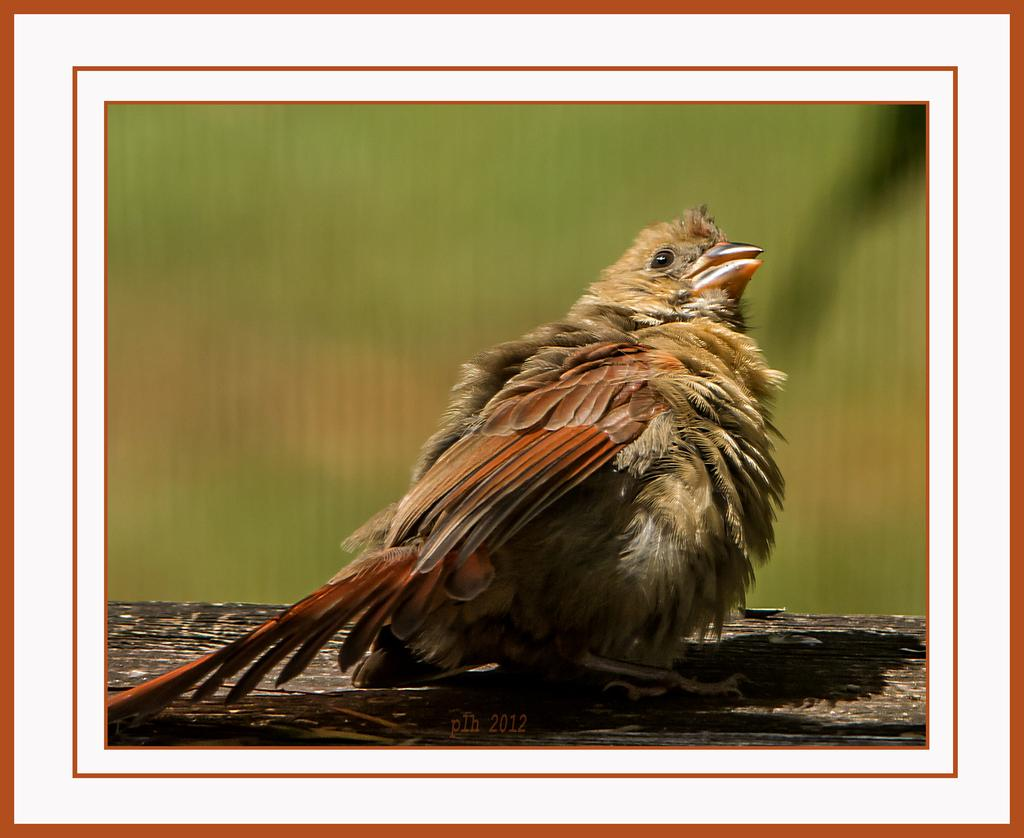What type of animal is in the image? There is a bird in the image. Can you describe the bird's appearance? The bird has brown and cream colors. Where is the bird located in the image? The bird is on a wooden surface. What color is the background of the image? The background of the image is green. What type of stew is being cooked on the wooden surface in the image? There is no stew present in the image; it features a bird on a wooden surface. How does the van help the bird in the image? There is no van present in the image, so it cannot help the bird. 